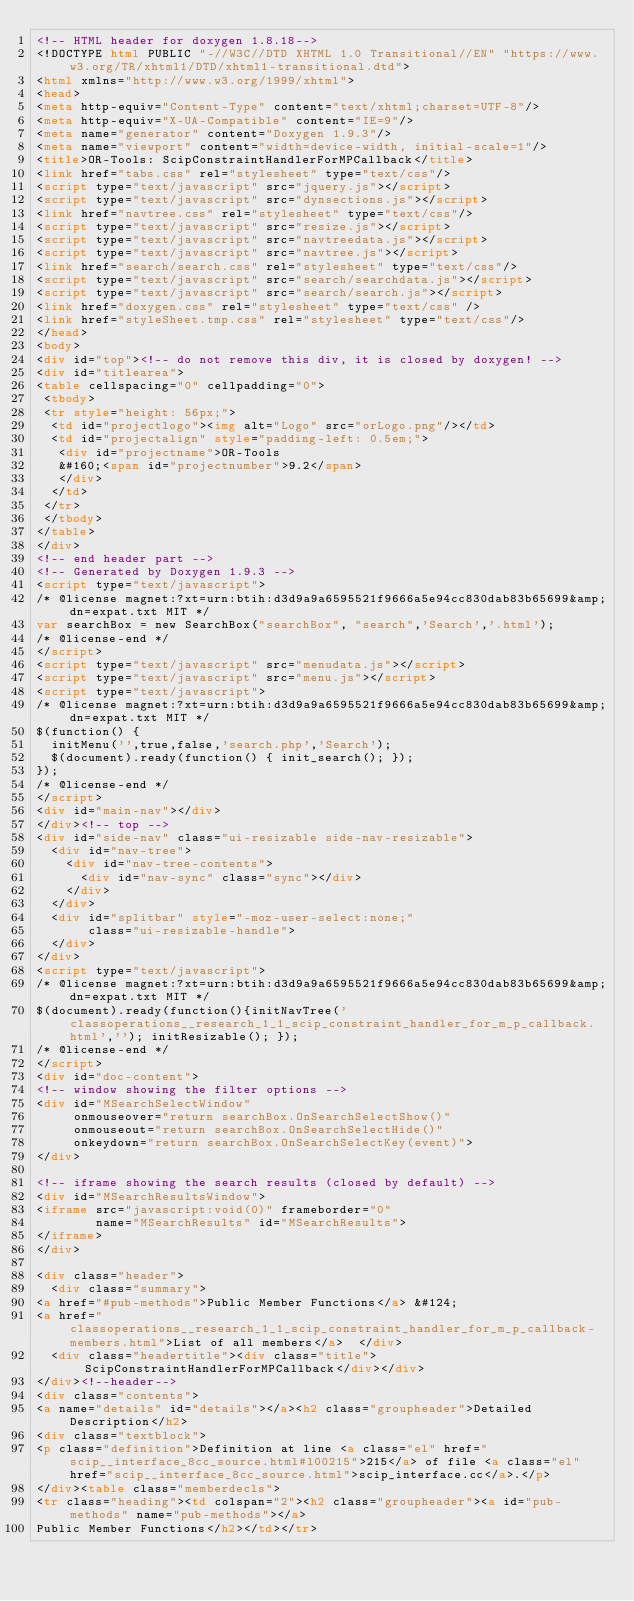Convert code to text. <code><loc_0><loc_0><loc_500><loc_500><_HTML_><!-- HTML header for doxygen 1.8.18-->
<!DOCTYPE html PUBLIC "-//W3C//DTD XHTML 1.0 Transitional//EN" "https://www.w3.org/TR/xhtml1/DTD/xhtml1-transitional.dtd">
<html xmlns="http://www.w3.org/1999/xhtml">
<head>
<meta http-equiv="Content-Type" content="text/xhtml;charset=UTF-8"/>
<meta http-equiv="X-UA-Compatible" content="IE=9"/>
<meta name="generator" content="Doxygen 1.9.3"/>
<meta name="viewport" content="width=device-width, initial-scale=1"/>
<title>OR-Tools: ScipConstraintHandlerForMPCallback</title>
<link href="tabs.css" rel="stylesheet" type="text/css"/>
<script type="text/javascript" src="jquery.js"></script>
<script type="text/javascript" src="dynsections.js"></script>
<link href="navtree.css" rel="stylesheet" type="text/css"/>
<script type="text/javascript" src="resize.js"></script>
<script type="text/javascript" src="navtreedata.js"></script>
<script type="text/javascript" src="navtree.js"></script>
<link href="search/search.css" rel="stylesheet" type="text/css"/>
<script type="text/javascript" src="search/searchdata.js"></script>
<script type="text/javascript" src="search/search.js"></script>
<link href="doxygen.css" rel="stylesheet" type="text/css" />
<link href="styleSheet.tmp.css" rel="stylesheet" type="text/css"/>
</head>
<body>
<div id="top"><!-- do not remove this div, it is closed by doxygen! -->
<div id="titlearea">
<table cellspacing="0" cellpadding="0">
 <tbody>
 <tr style="height: 56px;">
  <td id="projectlogo"><img alt="Logo" src="orLogo.png"/></td>
  <td id="projectalign" style="padding-left: 0.5em;">
   <div id="projectname">OR-Tools
   &#160;<span id="projectnumber">9.2</span>
   </div>
  </td>
 </tr>
 </tbody>
</table>
</div>
<!-- end header part -->
<!-- Generated by Doxygen 1.9.3 -->
<script type="text/javascript">
/* @license magnet:?xt=urn:btih:d3d9a9a6595521f9666a5e94cc830dab83b65699&amp;dn=expat.txt MIT */
var searchBox = new SearchBox("searchBox", "search",'Search','.html');
/* @license-end */
</script>
<script type="text/javascript" src="menudata.js"></script>
<script type="text/javascript" src="menu.js"></script>
<script type="text/javascript">
/* @license magnet:?xt=urn:btih:d3d9a9a6595521f9666a5e94cc830dab83b65699&amp;dn=expat.txt MIT */
$(function() {
  initMenu('',true,false,'search.php','Search');
  $(document).ready(function() { init_search(); });
});
/* @license-end */
</script>
<div id="main-nav"></div>
</div><!-- top -->
<div id="side-nav" class="ui-resizable side-nav-resizable">
  <div id="nav-tree">
    <div id="nav-tree-contents">
      <div id="nav-sync" class="sync"></div>
    </div>
  </div>
  <div id="splitbar" style="-moz-user-select:none;" 
       class="ui-resizable-handle">
  </div>
</div>
<script type="text/javascript">
/* @license magnet:?xt=urn:btih:d3d9a9a6595521f9666a5e94cc830dab83b65699&amp;dn=expat.txt MIT */
$(document).ready(function(){initNavTree('classoperations__research_1_1_scip_constraint_handler_for_m_p_callback.html',''); initResizable(); });
/* @license-end */
</script>
<div id="doc-content">
<!-- window showing the filter options -->
<div id="MSearchSelectWindow"
     onmouseover="return searchBox.OnSearchSelectShow()"
     onmouseout="return searchBox.OnSearchSelectHide()"
     onkeydown="return searchBox.OnSearchSelectKey(event)">
</div>

<!-- iframe showing the search results (closed by default) -->
<div id="MSearchResultsWindow">
<iframe src="javascript:void(0)" frameborder="0" 
        name="MSearchResults" id="MSearchResults">
</iframe>
</div>

<div class="header">
  <div class="summary">
<a href="#pub-methods">Public Member Functions</a> &#124;
<a href="classoperations__research_1_1_scip_constraint_handler_for_m_p_callback-members.html">List of all members</a>  </div>
  <div class="headertitle"><div class="title">ScipConstraintHandlerForMPCallback</div></div>
</div><!--header-->
<div class="contents">
<a name="details" id="details"></a><h2 class="groupheader">Detailed Description</h2>
<div class="textblock">
<p class="definition">Definition at line <a class="el" href="scip__interface_8cc_source.html#l00215">215</a> of file <a class="el" href="scip__interface_8cc_source.html">scip_interface.cc</a>.</p>
</div><table class="memberdecls">
<tr class="heading"><td colspan="2"><h2 class="groupheader"><a id="pub-methods" name="pub-methods"></a>
Public Member Functions</h2></td></tr></code> 